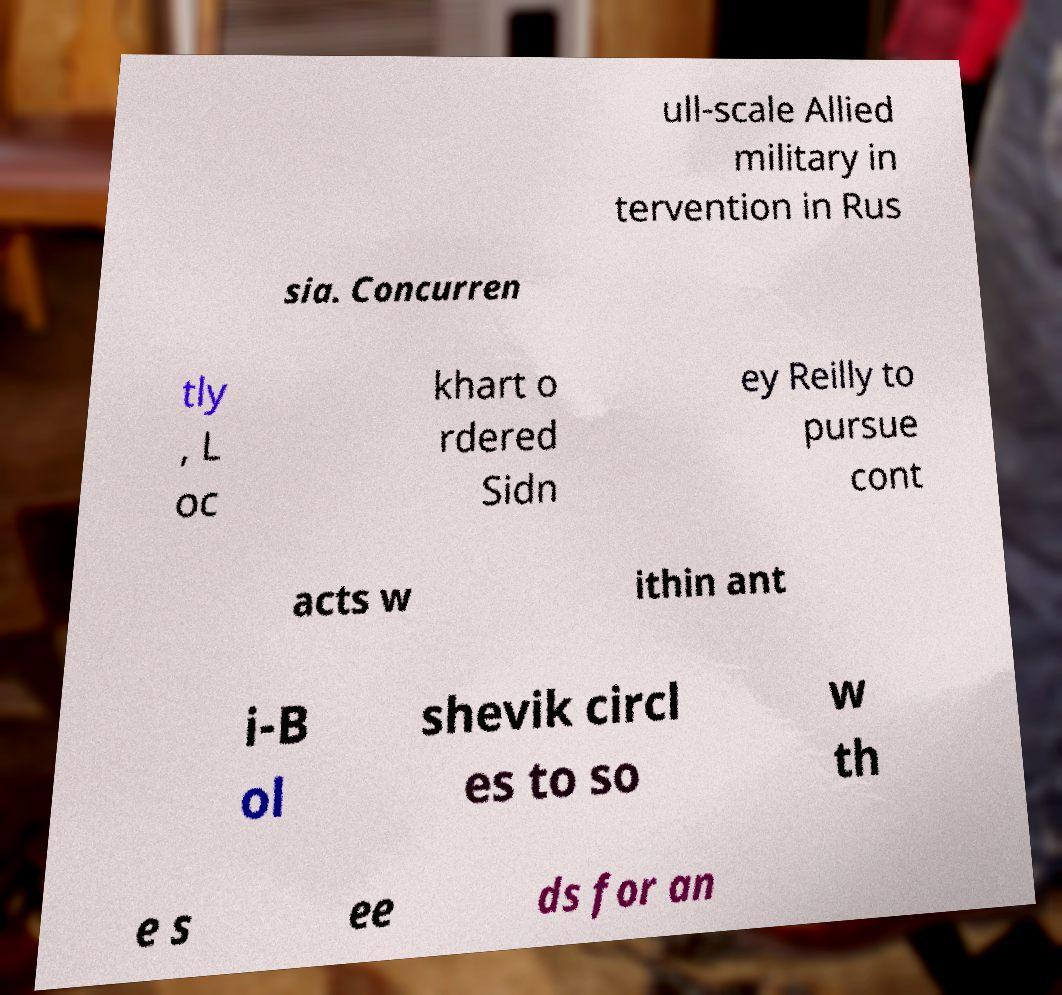Can you accurately transcribe the text from the provided image for me? ull-scale Allied military in tervention in Rus sia. Concurren tly , L oc khart o rdered Sidn ey Reilly to pursue cont acts w ithin ant i-B ol shevik circl es to so w th e s ee ds for an 